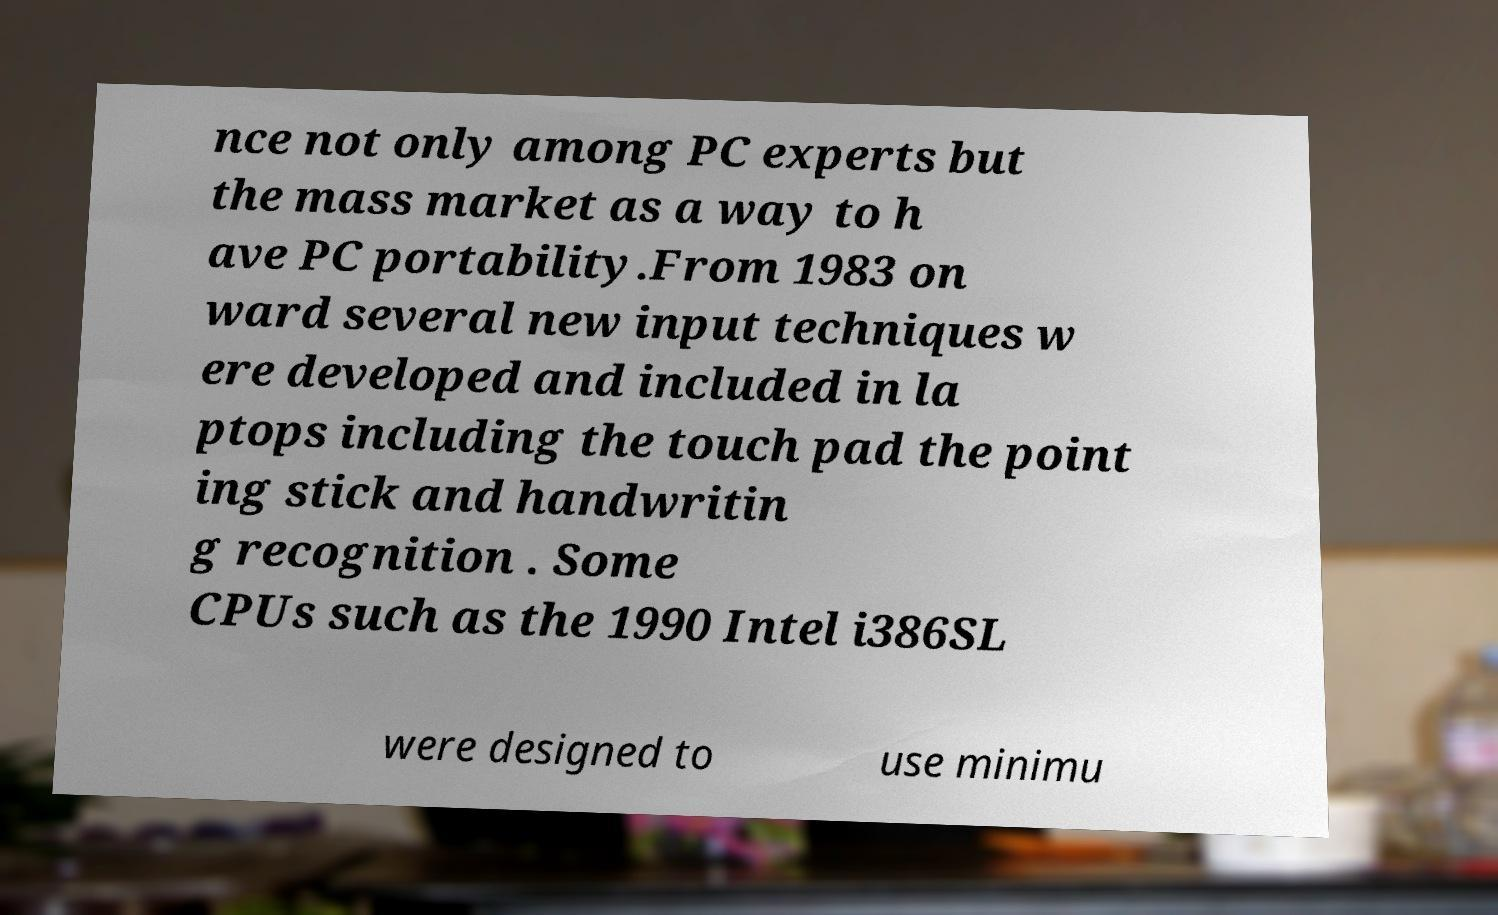Please read and relay the text visible in this image. What does it say? nce not only among PC experts but the mass market as a way to h ave PC portability.From 1983 on ward several new input techniques w ere developed and included in la ptops including the touch pad the point ing stick and handwritin g recognition . Some CPUs such as the 1990 Intel i386SL were designed to use minimu 